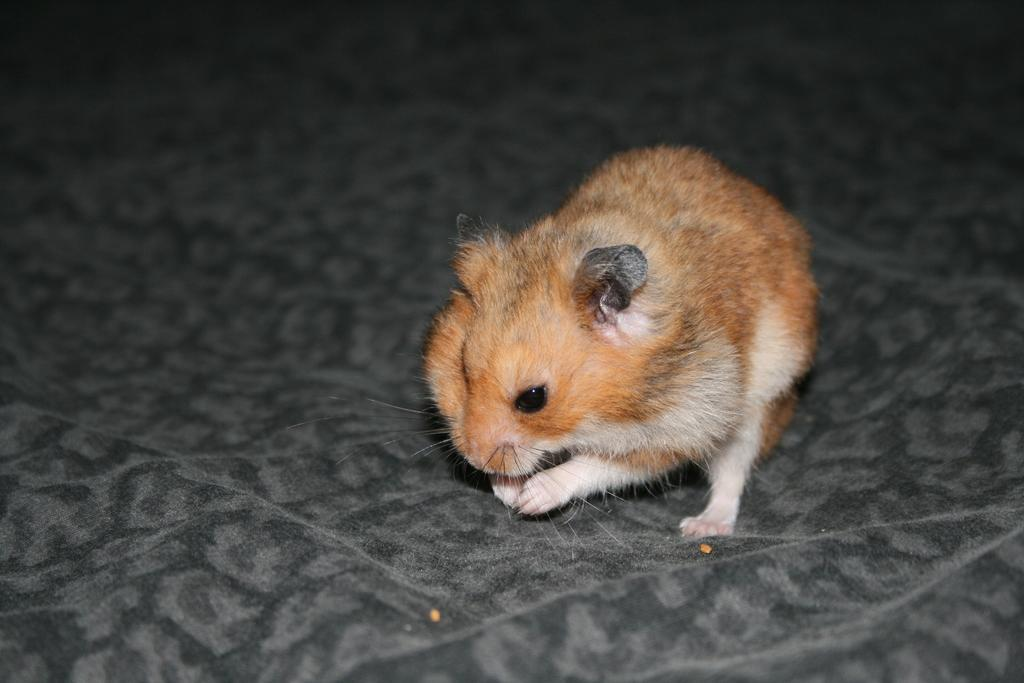What type of animal is in the image? There is a mouse present in the image. Where is the mouse located in the image? The mouse is on the floor. What type of fish can be seen swimming in the image? There is no fish present in the image; it features a mouse on the floor. Can you tell me how many women are visible in the image? There are no women present in the image; it features a mouse on the floor. 